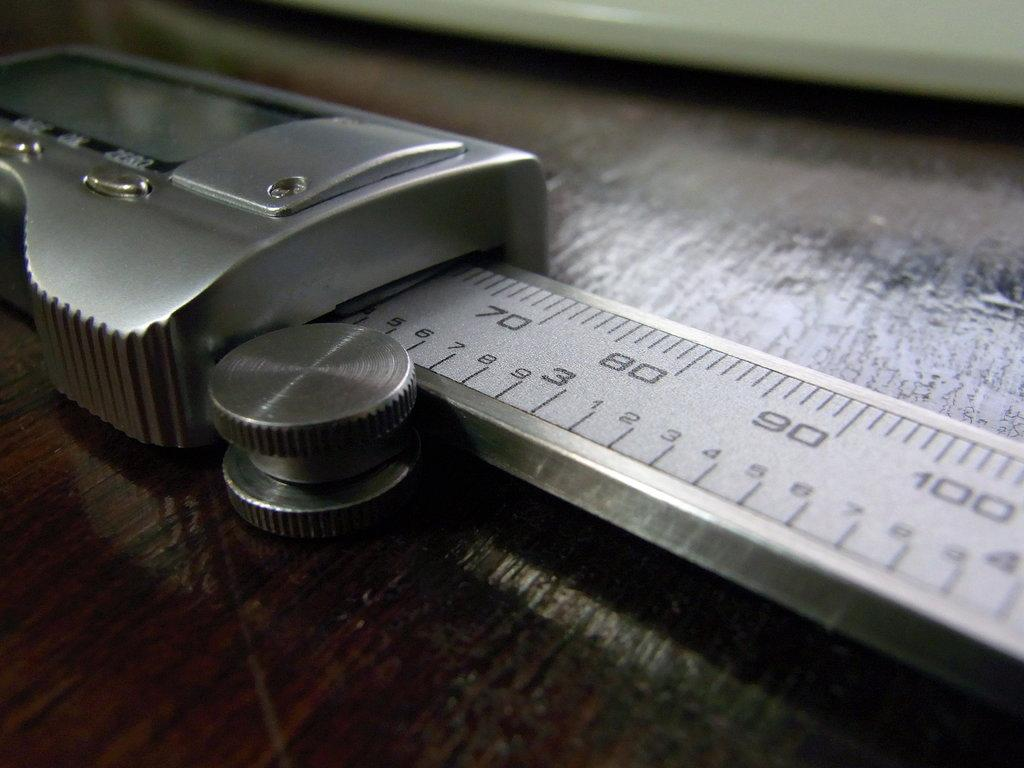Provide a one-sentence caption for the provided image. A silver measuring device goes up to at least 100 units. 